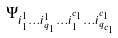<formula> <loc_0><loc_0><loc_500><loc_500>\Psi _ { i ^ { 1 } _ { 1 } \dots i ^ { 1 } _ { q _ { 1 } } \dots i ^ { c _ { 1 } } _ { 1 } \dots i ^ { c _ { 1 } } _ { q _ { c _ { 1 } } } }</formula> 